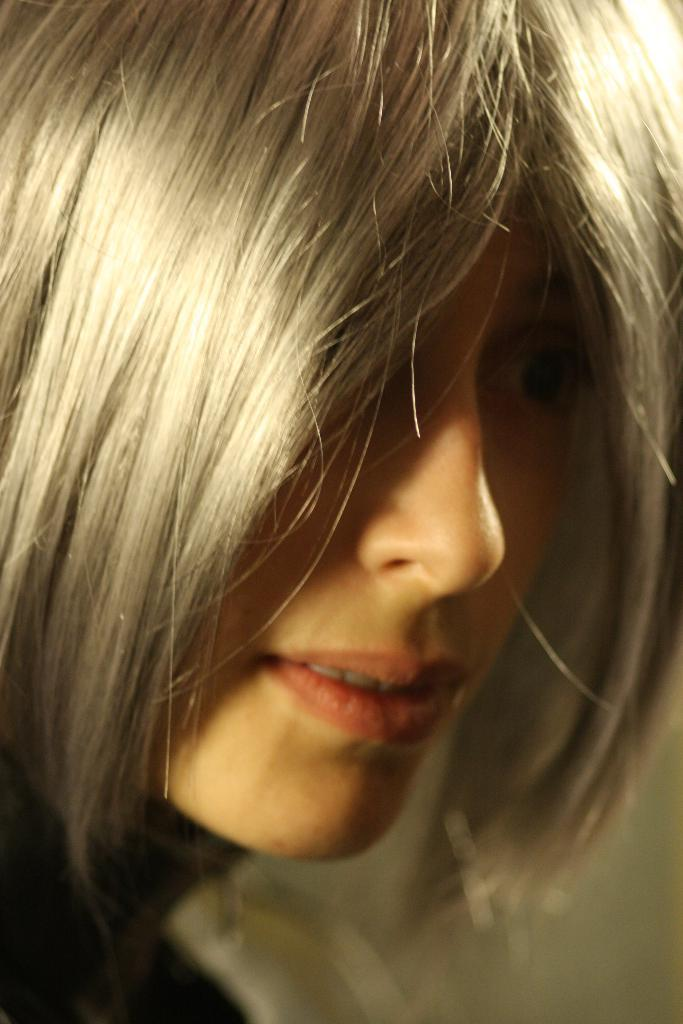What is the main subject of the image? There is a woman in the image. Can you describe the woman's appearance? The woman has blond hair. What type of cork is the woman holding in the image? There is no cork present in the image. Is the woman surrounded by smoke in the image? There is no smoke present in the image. 